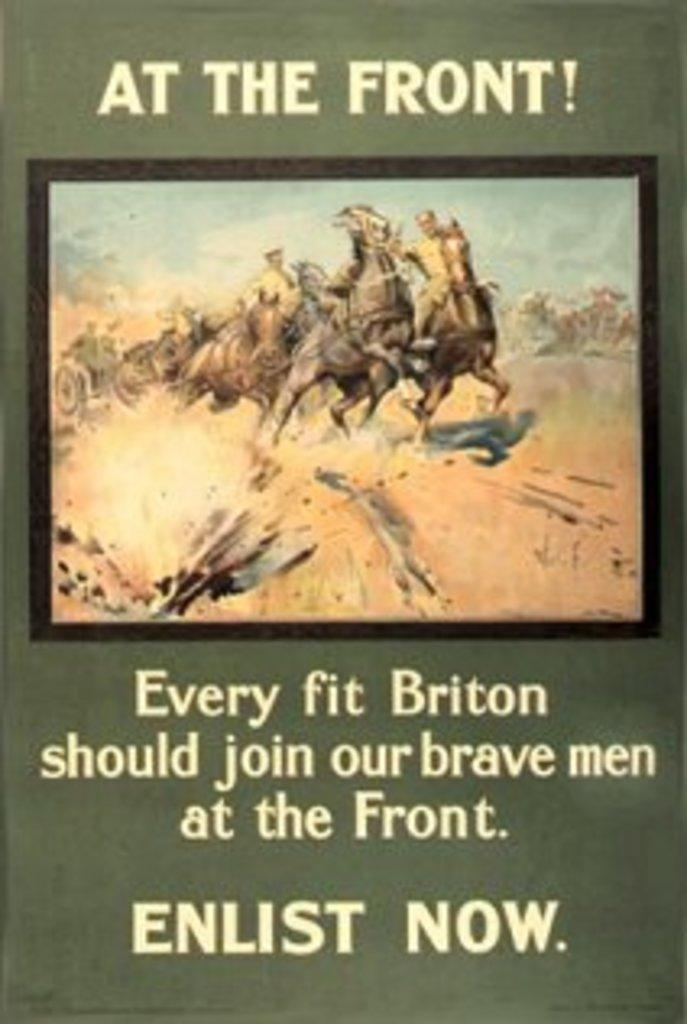Provide a one-sentence caption for the provided image. An ad calling for every firt briton to enlist now. 